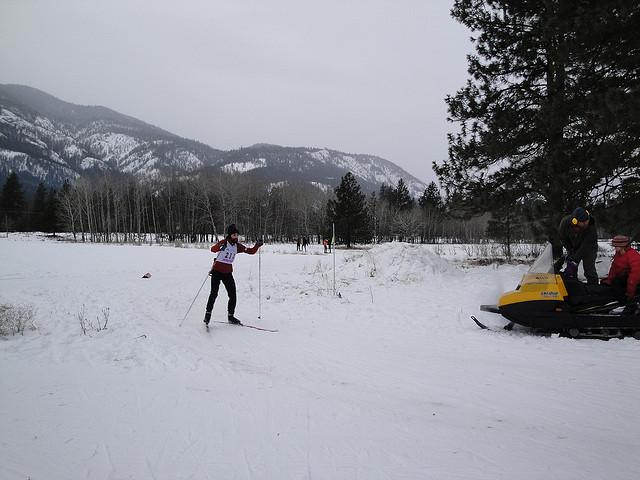What is the name of the yellow vehicle the man in red is on? Please explain your reasoning. snowmobile. People on a yellow and black snow machine are stopped in the snow near a skier. snow machines are used by emergency personal and others in cold climates. 